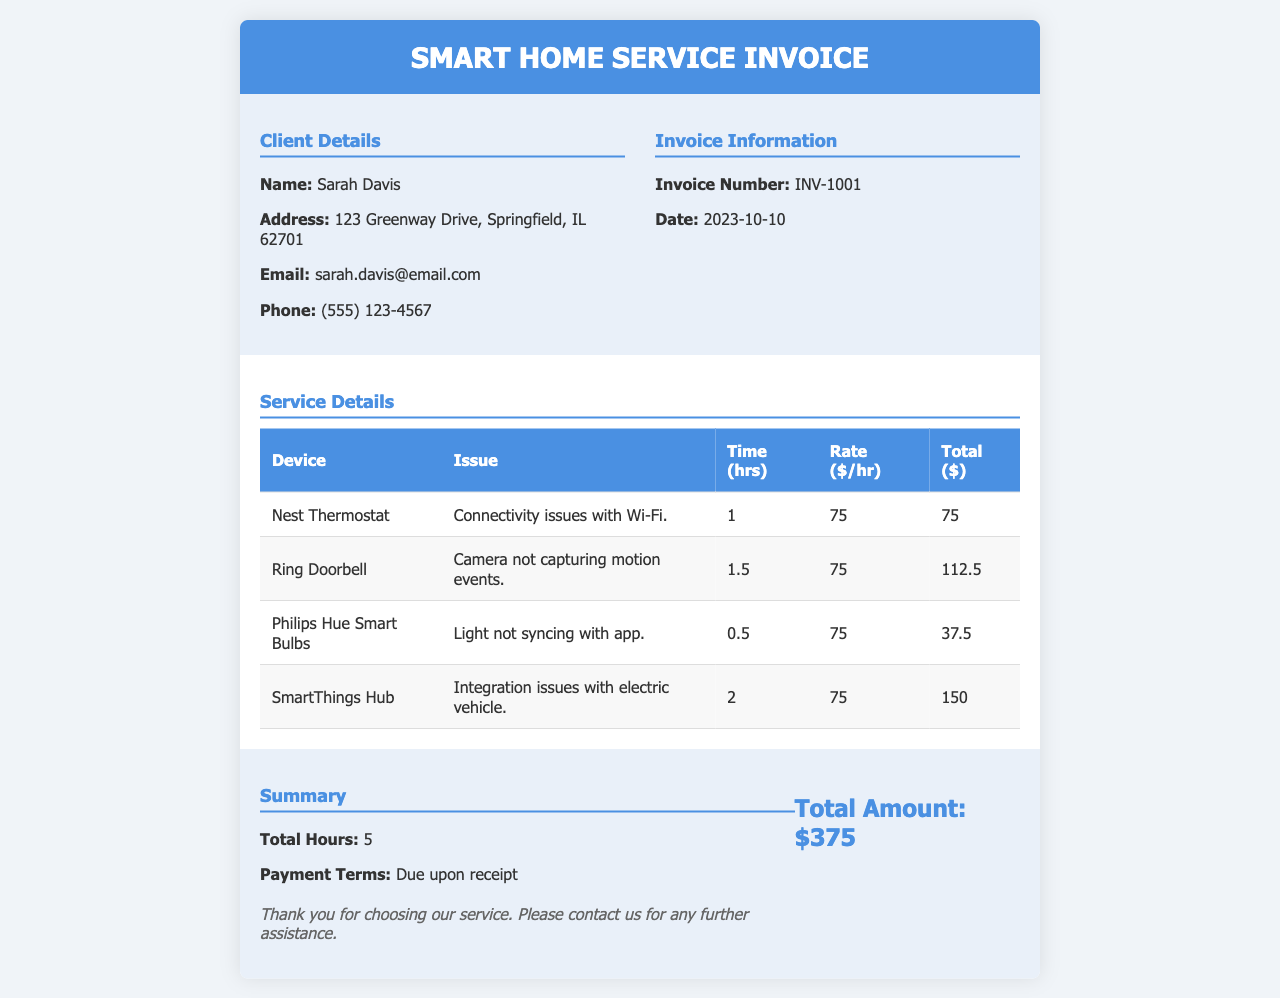What is the client's name? The client's name is specified in the client details section of the invoice.
Answer: Sarah Davis What is the invoice number? The invoice number is provided in the invoice information section.
Answer: INV-1001 How much was charged for the SmartThings Hub? The total charge for the SmartThings Hub is calculated in the service details table.
Answer: 150 What is the total amount due? The total amount due is listed in the summary section of the invoice.
Answer: $375 How many total hours were worked? The total hours are summarized in the summary section, combining all the time spent on repairs.
Answer: 5 What issue was reported with the Ring Doorbell? The issue with the Ring Doorbell is detailed in the service details table.
Answer: Camera not capturing motion events What is the hourly rate charged? The hourly rate for services is indicated in the service details table as a standard rate.
Answer: $75 What payment terms are specified? The payment terms are mentioned in the summary section of the invoice.
Answer: Due upon receipt 